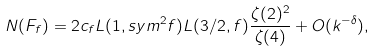Convert formula to latex. <formula><loc_0><loc_0><loc_500><loc_500>N ( F _ { f } ) = 2 c _ { f } L ( 1 , s y m ^ { 2 } f ) L ( 3 / 2 , f ) \frac { \zeta ( 2 ) ^ { 2 } } { \zeta ( 4 ) } + O ( k ^ { - \delta } ) ,</formula> 